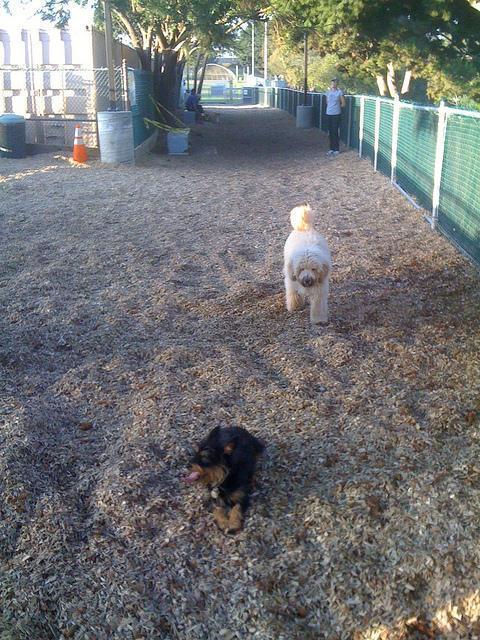How many dogs are there?
Give a very brief answer. 2. 